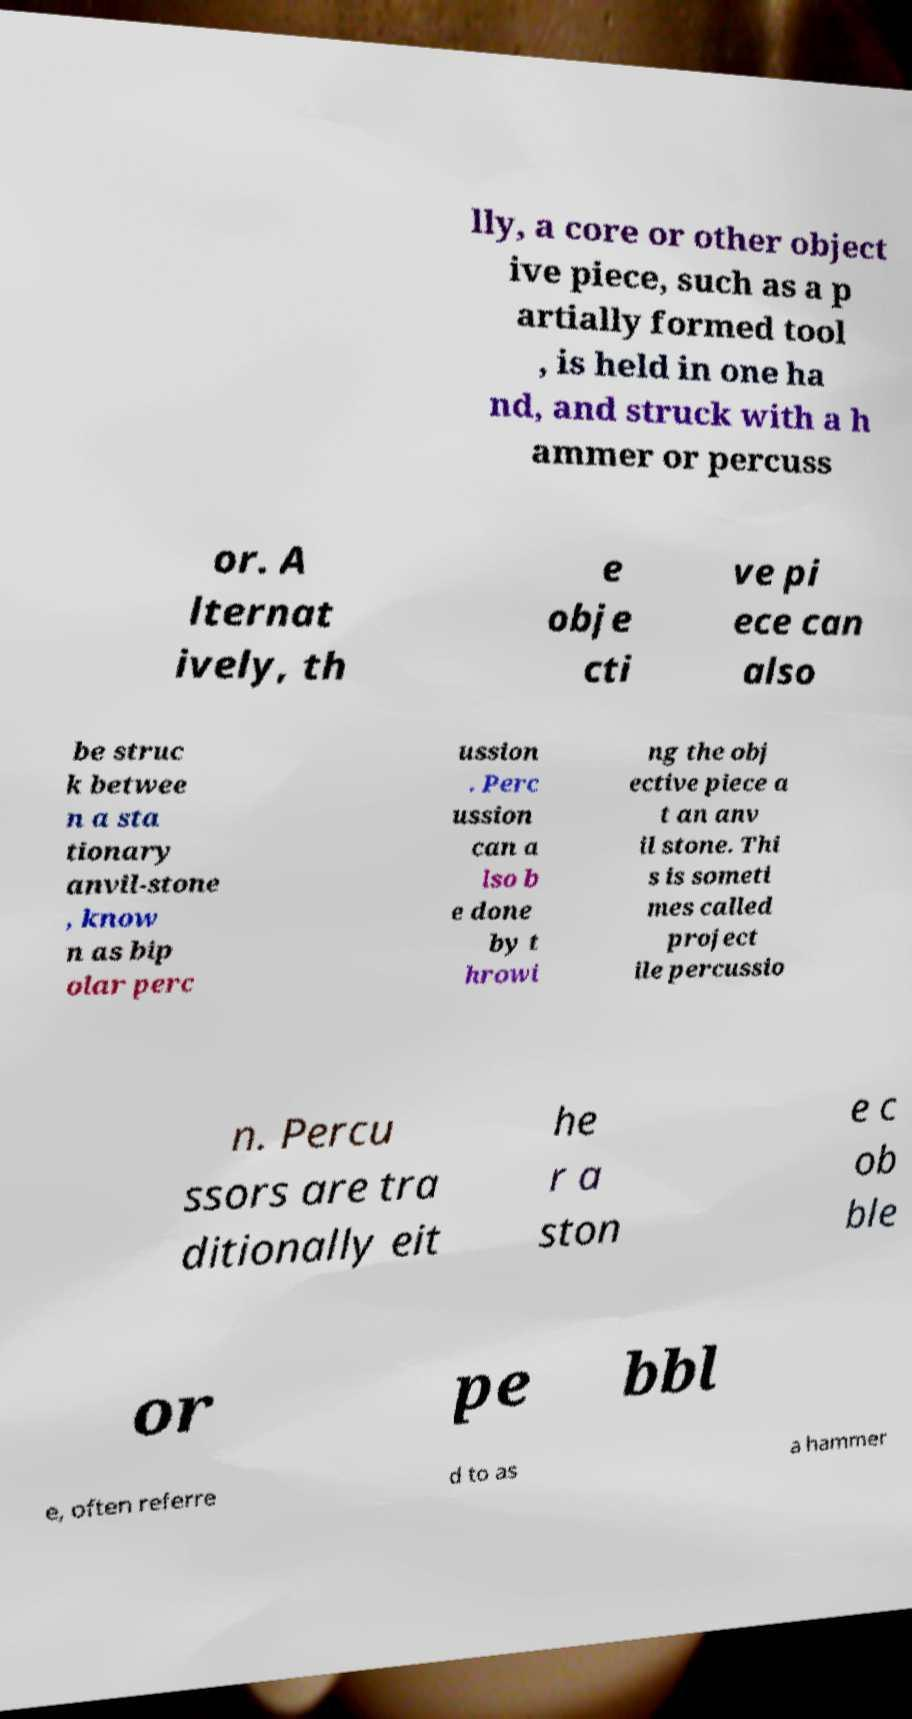There's text embedded in this image that I need extracted. Can you transcribe it verbatim? lly, a core or other object ive piece, such as a p artially formed tool , is held in one ha nd, and struck with a h ammer or percuss or. A lternat ively, th e obje cti ve pi ece can also be struc k betwee n a sta tionary anvil-stone , know n as bip olar perc ussion . Perc ussion can a lso b e done by t hrowi ng the obj ective piece a t an anv il stone. Thi s is someti mes called project ile percussio n. Percu ssors are tra ditionally eit he r a ston e c ob ble or pe bbl e, often referre d to as a hammer 